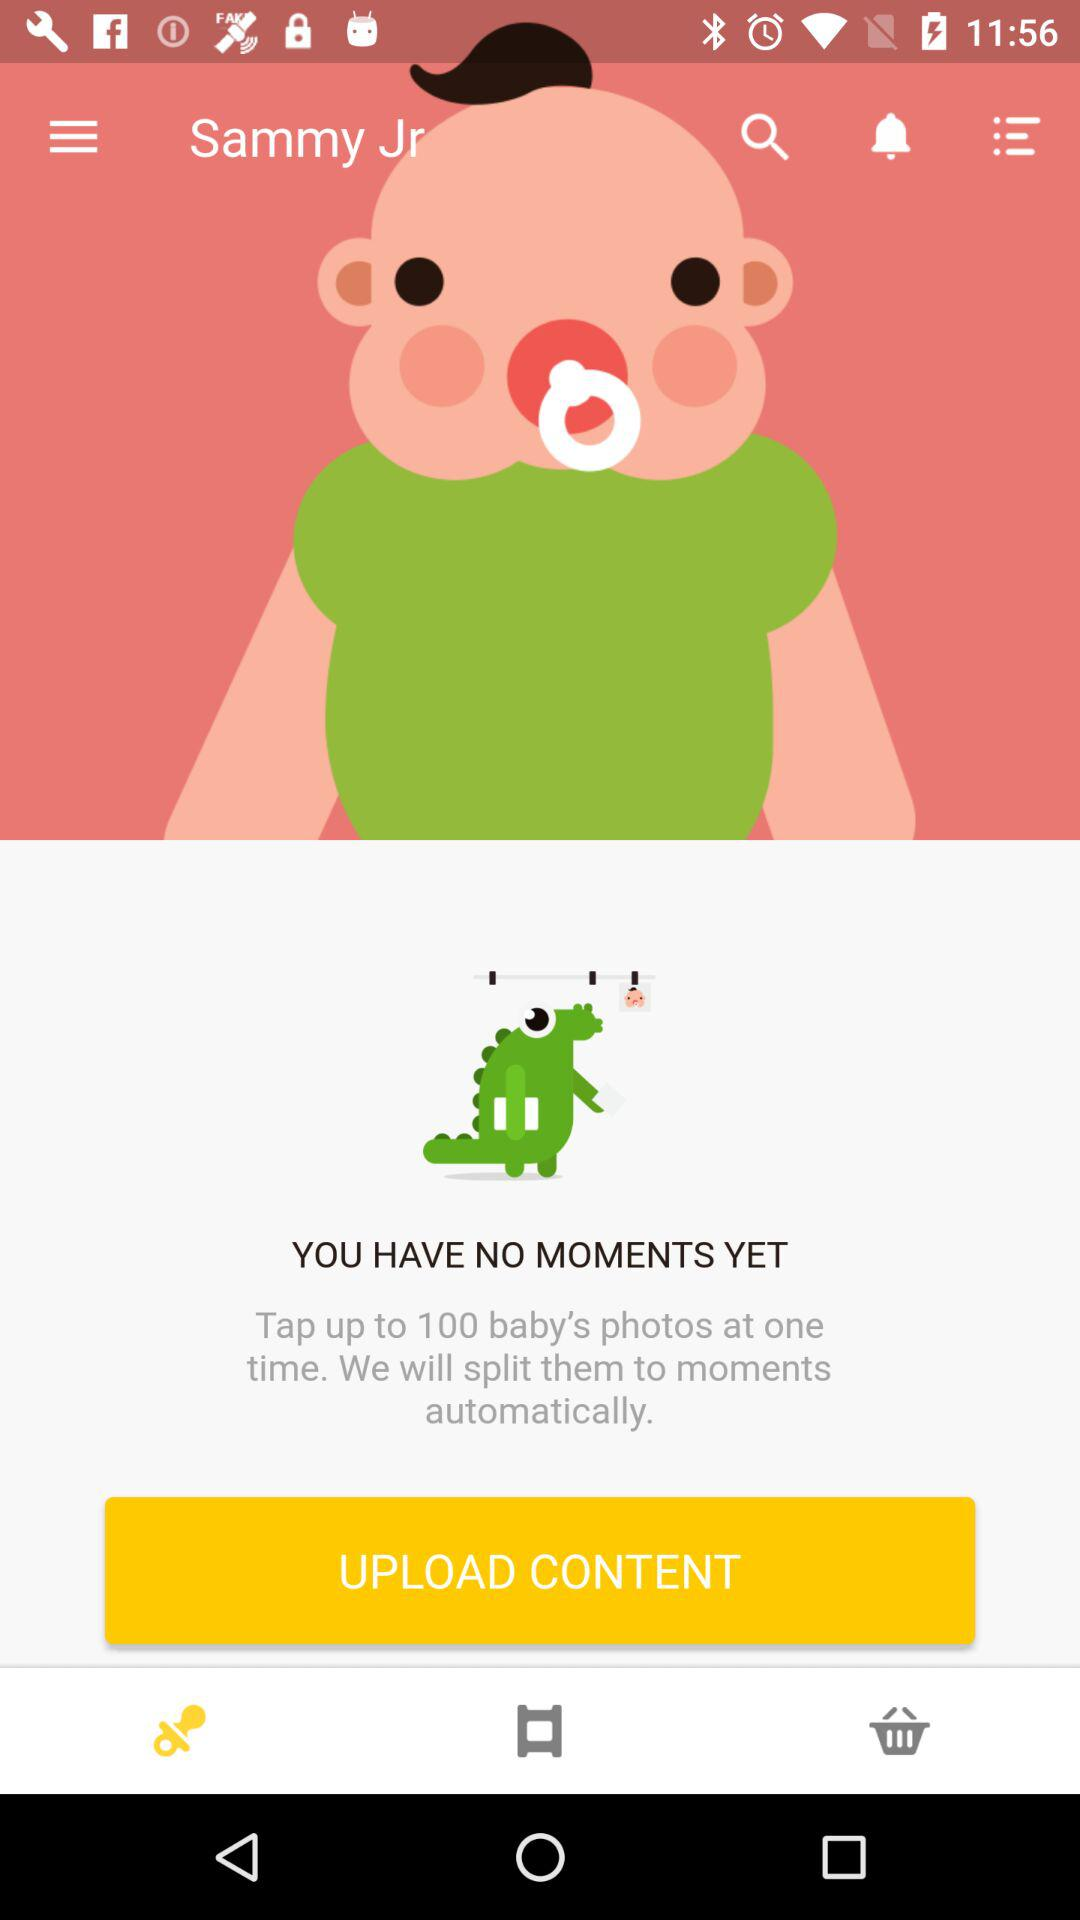How many more moments can the user create?
Answer the question using a single word or phrase. 100 